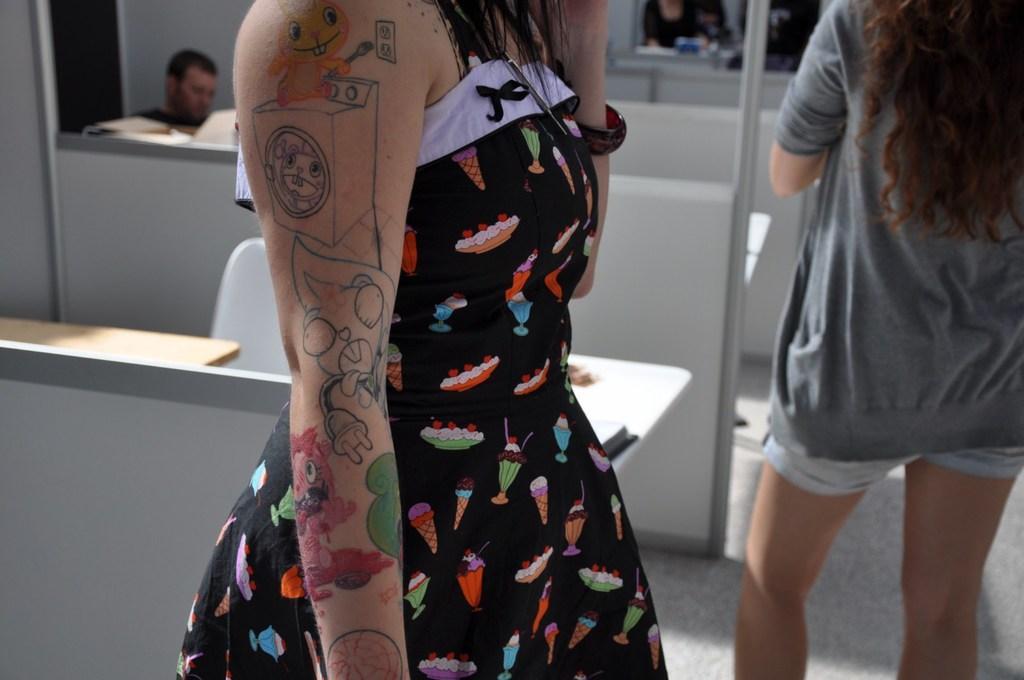Can you describe this image briefly? In the foreground of this image, there is a woman standing in black dress and there are few sketches on her hand. In the background, there is another woman standing, tables, chairs, desks and few persons sitting in the background. 